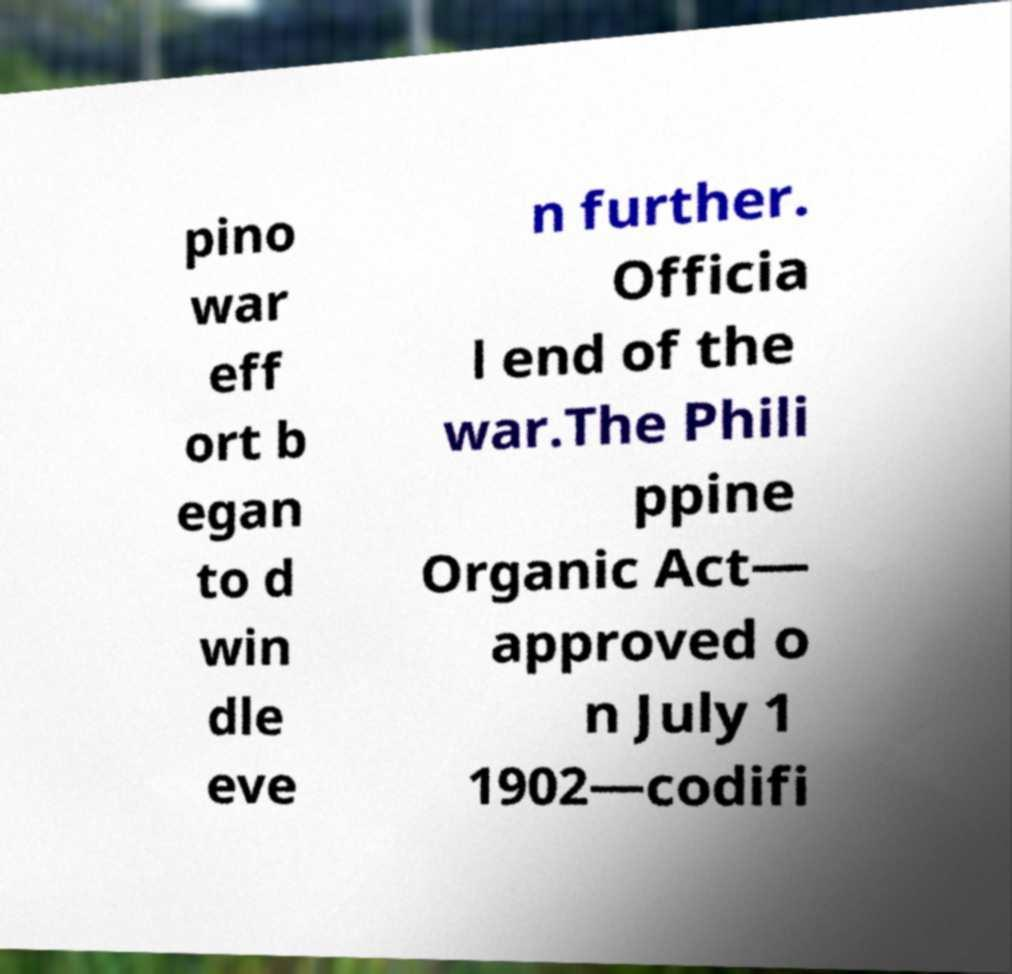Can you accurately transcribe the text from the provided image for me? pino war eff ort b egan to d win dle eve n further. Officia l end of the war.The Phili ppine Organic Act— approved o n July 1 1902—codifi 